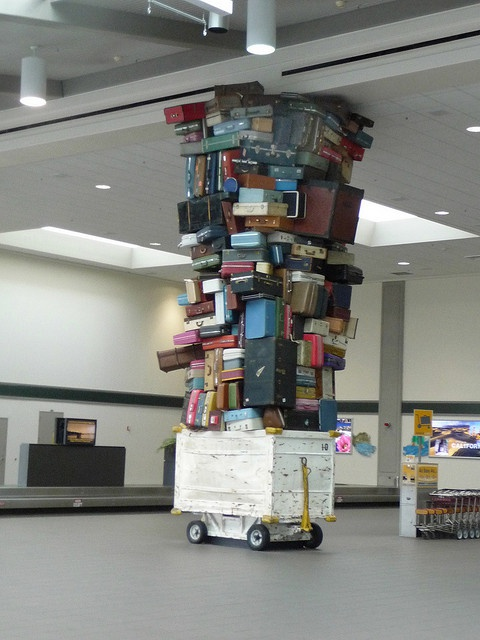Describe the objects in this image and their specific colors. I can see suitcase in white, black, gray, maroon, and darkgray tones, suitcase in white, black, purple, and darkblue tones, suitcase in white, black, gray, purple, and darkblue tones, suitcase in white, blue, gray, darkgray, and teal tones, and suitcase in white, black, purple, and darkgreen tones in this image. 